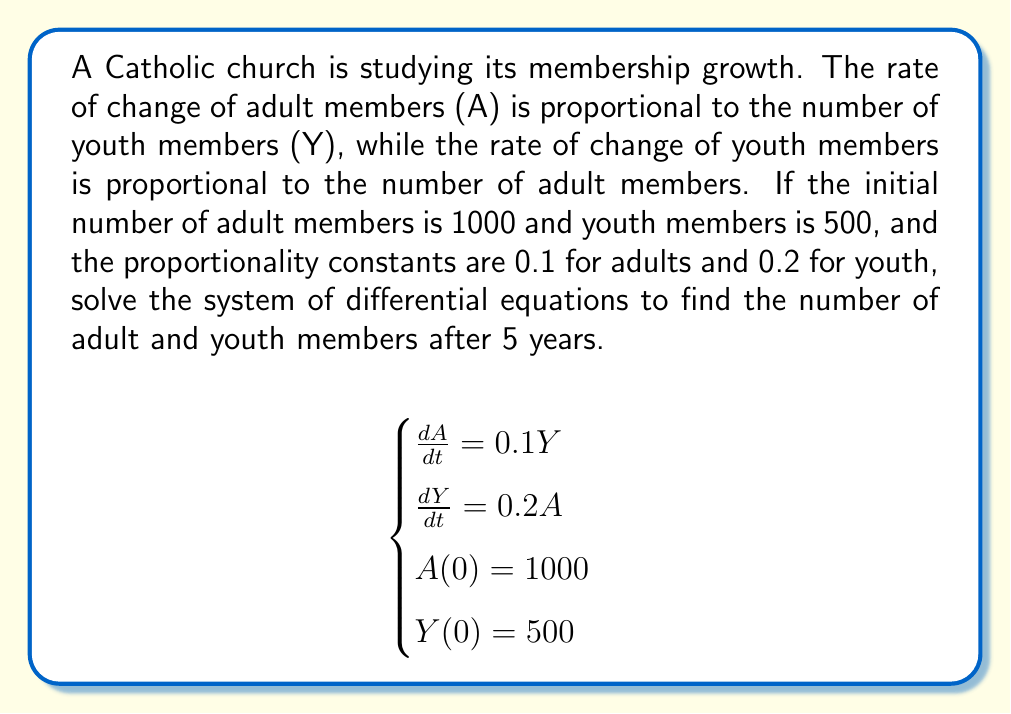Solve this math problem. To solve this system of differential equations, we'll follow these steps:

1) First, we need to find the general solution. The system is of the form:
   $$\frac{d}{dt}\begin{pmatrix}A\\Y\end{pmatrix} = \begin{pmatrix}0 & 0.1\\0.2 & 0\end{pmatrix}\begin{pmatrix}A\\Y\end{pmatrix}$$

2) The characteristic equation is:
   $$\det(\lambda I - A) = \lambda^2 - 0.02 = 0$$

3) Solving this, we get eigenvalues $\lambda = \pm \sqrt{0.02} = \pm 0.1414$

4) The general solution is of the form:
   $$\begin{pmatrix}A\\Y\end{pmatrix} = c_1e^{0.1414t}\begin{pmatrix}1\\1.414\end{pmatrix} + c_2e^{-0.1414t}\begin{pmatrix}1\\-1.414\end{pmatrix}$$

5) Using the initial conditions:
   $$\begin{cases}
   1000 = c_1 + c_2 \\
   500 = 1.414c_1 - 1.414c_2
   \end{cases}$$

6) Solving this system:
   $$c_1 = 530.59, c_2 = 469.41$$

7) Therefore, the solution is:
   $$A(t) = 530.59e^{0.1414t} + 469.41e^{-0.1414t}$$
   $$Y(t) = 750.25e^{0.1414t} - 663.75e^{-0.1414t}$$

8) To find the values after 5 years, we substitute t = 5:
   $$A(5) = 530.59e^{0.707} + 469.41e^{-0.707} \approx 1414.21$$
   $$Y(5) = 750.25e^{0.707} - 663.75e^{-0.707} \approx 1000.00$$
Answer: After 5 years: Adult members ≈ 1414, Youth members ≈ 1000 